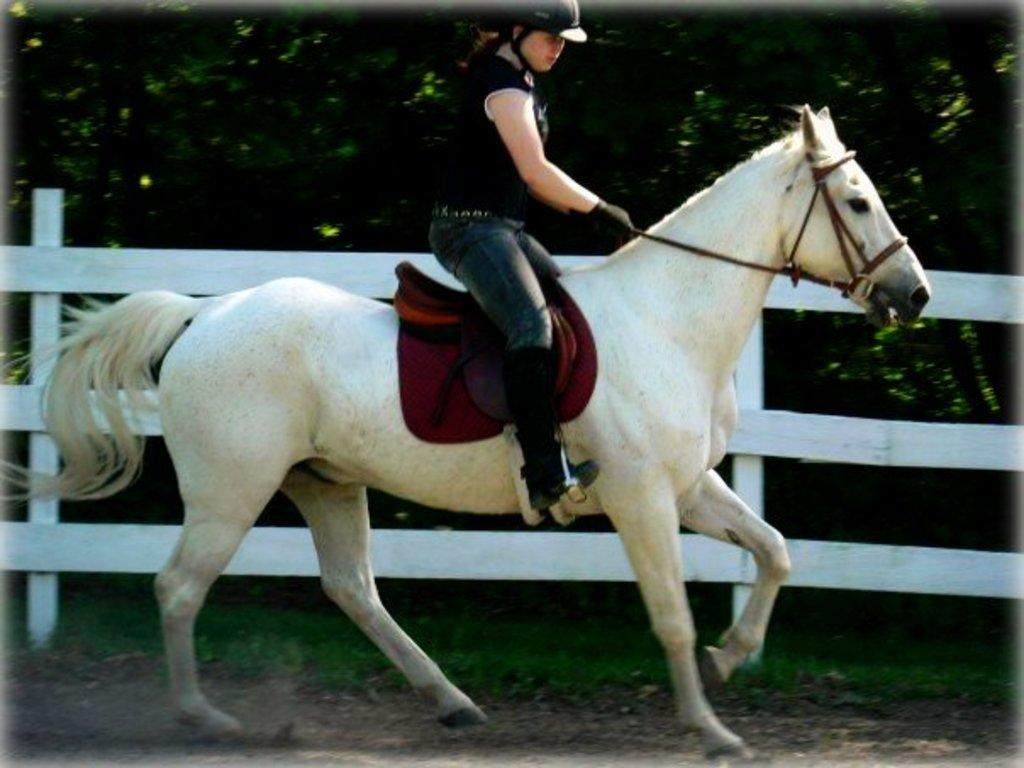What type of natural elements can be seen in the image? There are trees in the image. Who is present in the image? There is a woman in the image. What is the woman doing in the image? The woman is sitting on a white-colored horse. What type of collar is the horse wearing in the image? There is no collar visible on the horse in the image. What type of can is being used by the woman in the image? There is no can present in the image; the woman is sitting on a horse. 